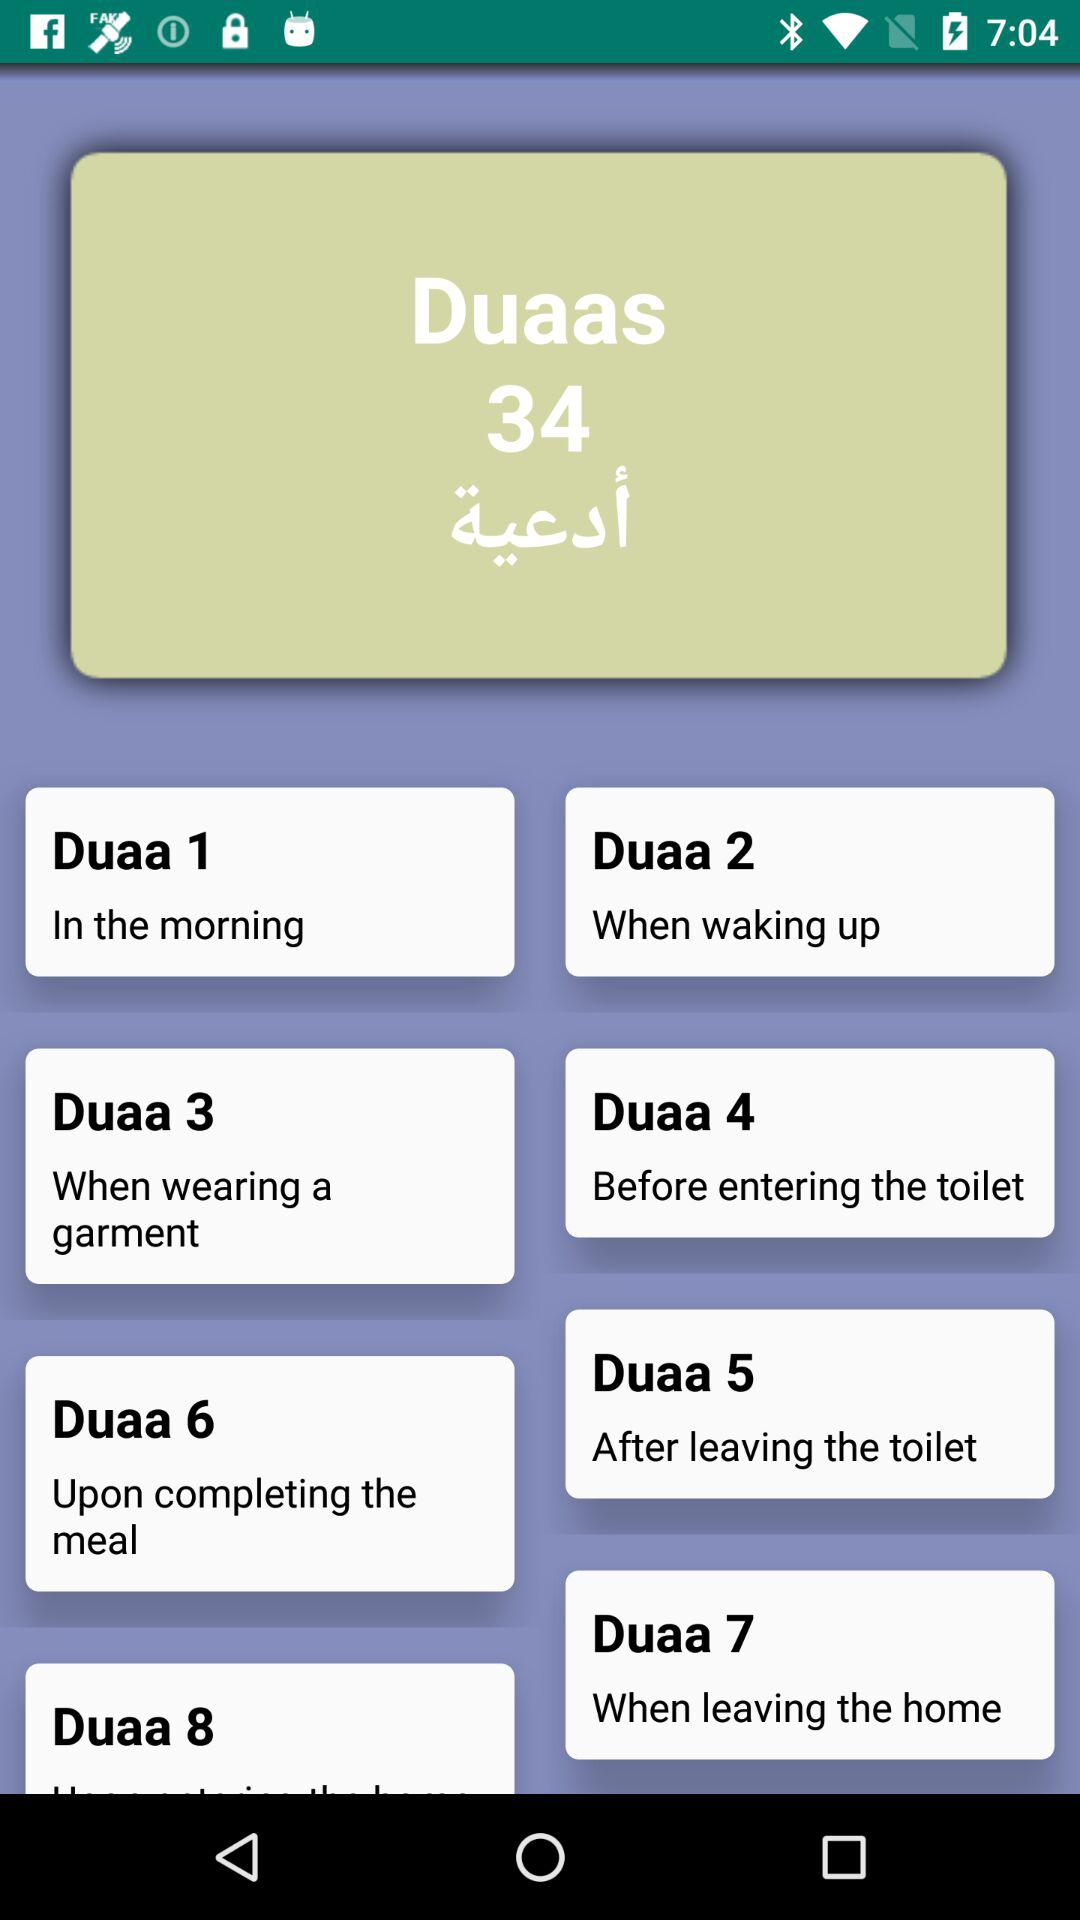Which "Duaa" is recited before entering the toilet? Before entering the toilet, "Duaa 4" is recited. 